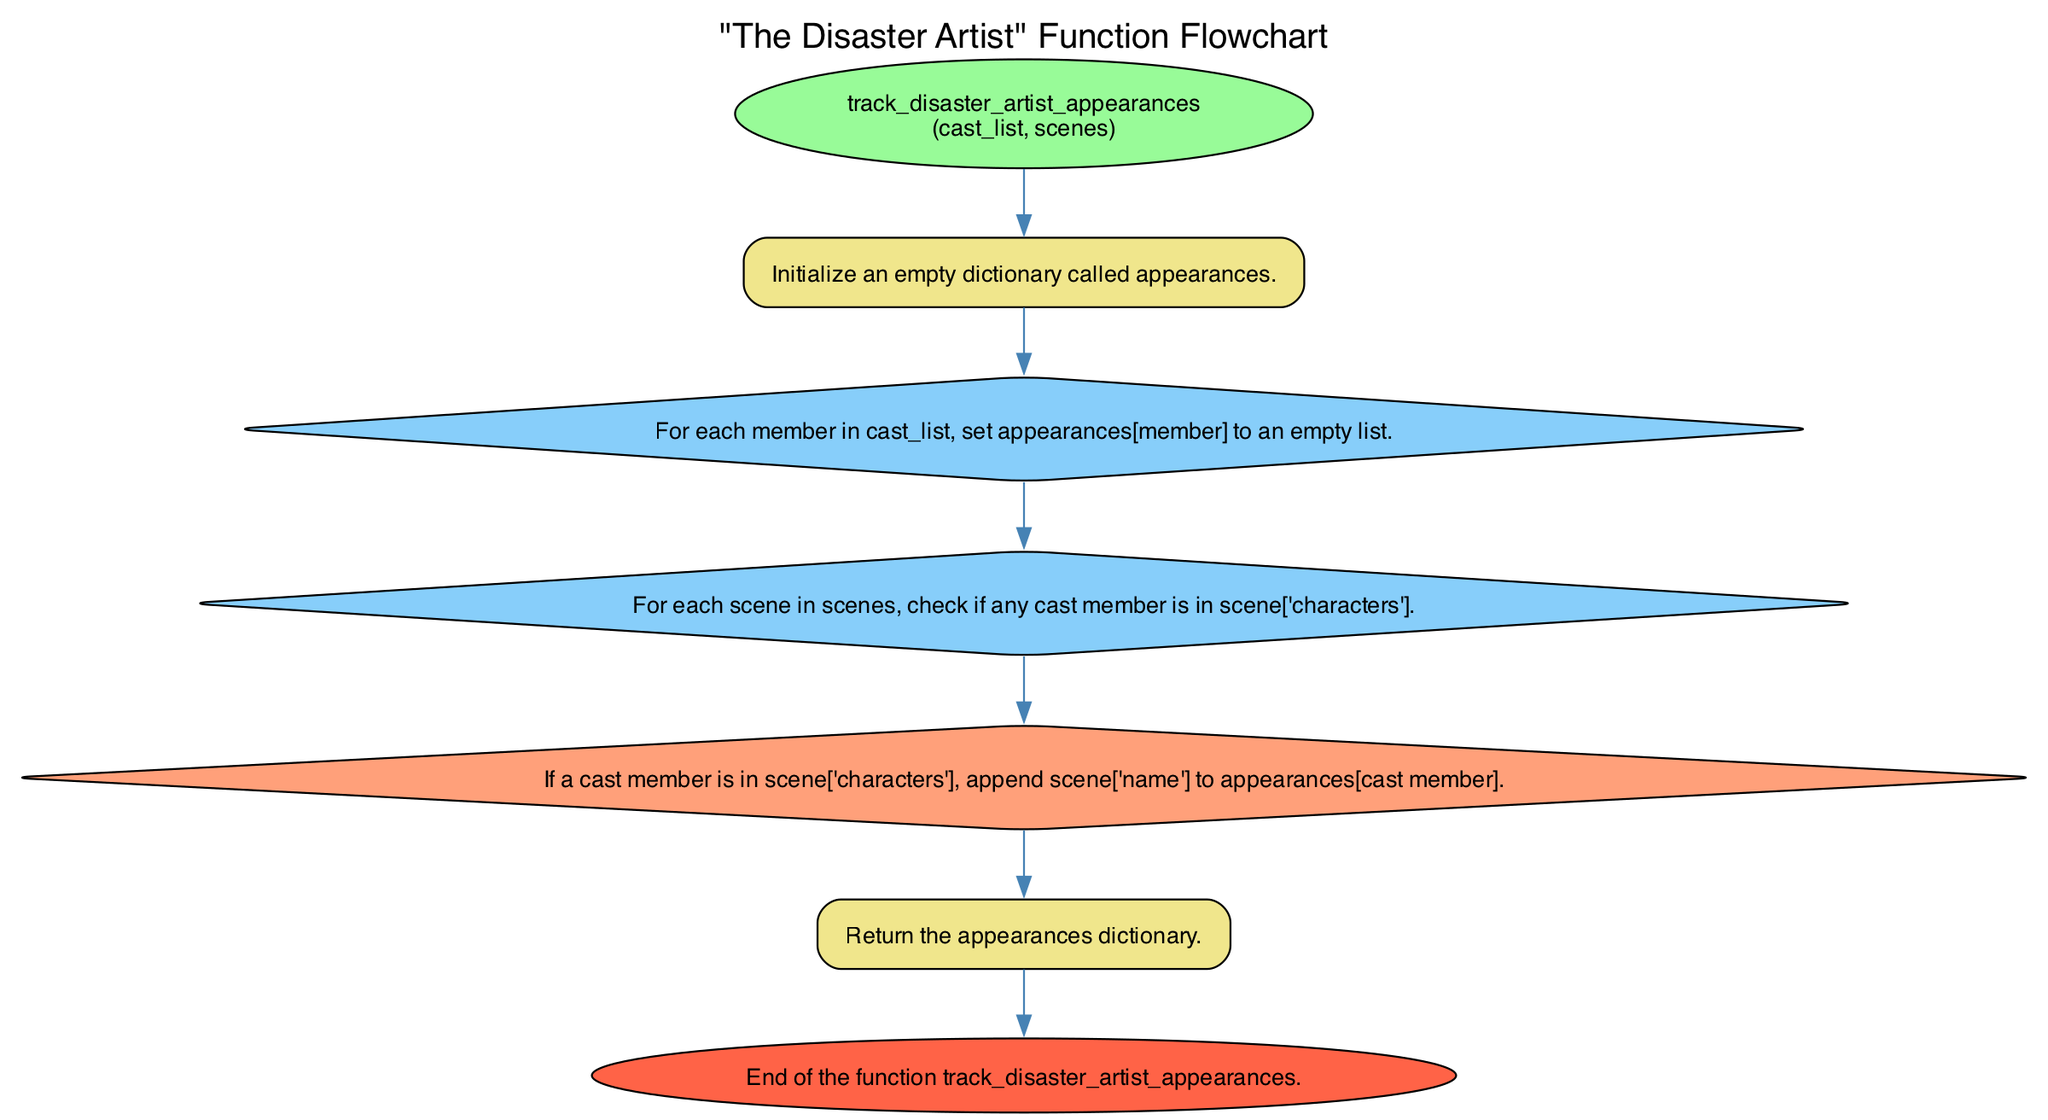what is the function name in the diagram? The function name is shown in the start node as "track_disaster_artist_appearances".
Answer: track_disaster_artist_appearances how many parameters does the function accept? The diagram indicates that the function takes two parameters, "cast_list" and "scenes".
Answer: 2 what is the first step in the function? The first step, as noted in the diagram, is to define the function with its input parameters.
Answer: Define a function track_disaster_artist_appearances that takes cast_list and scenes as input what type of node comes after the initialization step? After the initialization step, which is a standard step, the next node is a loop that processes each member in the cast list.
Answer: loop how many steps are there in total in the function? By counting each node described in the diagram, there are six steps before reaching the end node.
Answer: 6 which node describes checking if a member is in a scene? The diagram includes a nested loop node that refers to checking if any cast member appears in the scene's characters.
Answer: For each scene in scenes, check if any cast member is in scene['characters'] what does the condition node specifically do in the process? The condition node specifies that if a cast member is in the scene's characters, the scene's name should be appended to their appearances list.
Answer: If a cast member is in scene['characters'], append scene['name'] to appearances[cast member] what type of flowchart is this? This flowchart depicts a process outlined in a programming function, specifically tracking appearances in a film.
Answer: Function flowchart how does the function conclude? The function wraps up by returning the appearances dictionary that was built throughout the process.
Answer: Return the appearances dictionary 